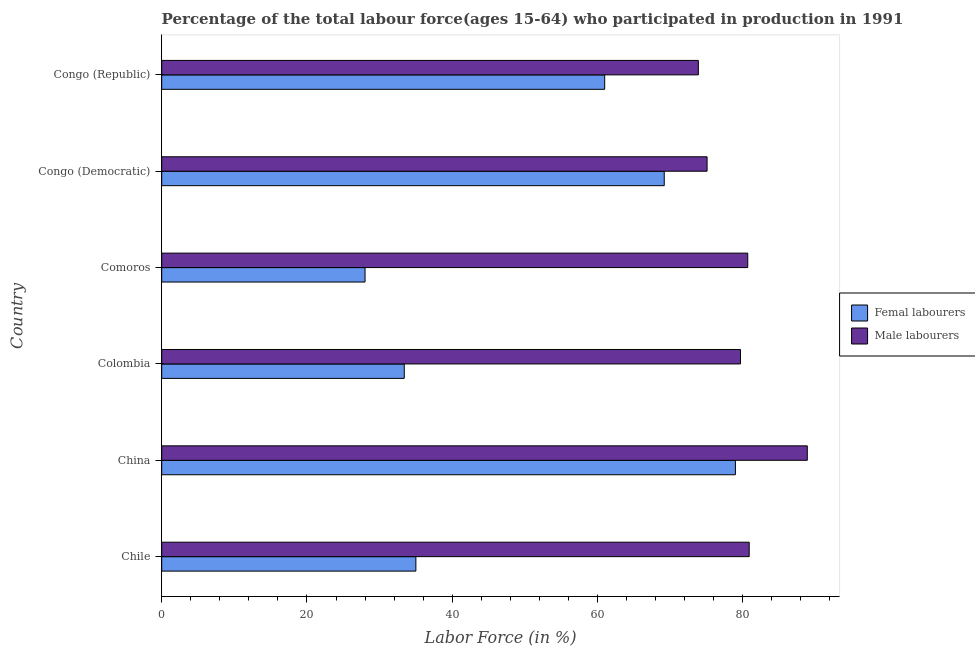How many bars are there on the 2nd tick from the bottom?
Your answer should be compact. 2. What is the label of the 3rd group of bars from the top?
Give a very brief answer. Comoros. In how many cases, is the number of bars for a given country not equal to the number of legend labels?
Give a very brief answer. 0. What is the percentage of male labour force in China?
Make the answer very short. 88.9. Across all countries, what is the maximum percentage of male labour force?
Ensure brevity in your answer.  88.9. Across all countries, what is the minimum percentage of female labor force?
Make the answer very short. 28. In which country was the percentage of female labor force maximum?
Provide a succinct answer. China. In which country was the percentage of male labour force minimum?
Ensure brevity in your answer.  Congo (Republic). What is the total percentage of female labor force in the graph?
Provide a succinct answer. 305.6. What is the difference between the percentage of female labor force in Colombia and the percentage of male labour force in Chile?
Provide a short and direct response. -47.5. What is the average percentage of female labor force per country?
Provide a short and direct response. 50.93. What is the ratio of the percentage of female labor force in Comoros to that in Congo (Republic)?
Your response must be concise. 0.46. Is the percentage of male labour force in Chile less than that in Congo (Democratic)?
Give a very brief answer. No. What is the difference between the highest and the second highest percentage of female labor force?
Keep it short and to the point. 9.8. In how many countries, is the percentage of female labor force greater than the average percentage of female labor force taken over all countries?
Offer a very short reply. 3. What does the 1st bar from the top in Chile represents?
Make the answer very short. Male labourers. What does the 1st bar from the bottom in Comoros represents?
Offer a very short reply. Femal labourers. Are all the bars in the graph horizontal?
Provide a short and direct response. Yes. What is the difference between two consecutive major ticks on the X-axis?
Give a very brief answer. 20. Does the graph contain any zero values?
Keep it short and to the point. No. How many legend labels are there?
Make the answer very short. 2. What is the title of the graph?
Make the answer very short. Percentage of the total labour force(ages 15-64) who participated in production in 1991. Does "Excluding technical cooperation" appear as one of the legend labels in the graph?
Your response must be concise. No. What is the label or title of the X-axis?
Your answer should be compact. Labor Force (in %). What is the label or title of the Y-axis?
Your response must be concise. Country. What is the Labor Force (in %) in Femal labourers in Chile?
Ensure brevity in your answer.  35. What is the Labor Force (in %) in Male labourers in Chile?
Offer a very short reply. 80.9. What is the Labor Force (in %) of Femal labourers in China?
Your answer should be compact. 79. What is the Labor Force (in %) in Male labourers in China?
Give a very brief answer. 88.9. What is the Labor Force (in %) in Femal labourers in Colombia?
Your response must be concise. 33.4. What is the Labor Force (in %) of Male labourers in Colombia?
Keep it short and to the point. 79.7. What is the Labor Force (in %) of Femal labourers in Comoros?
Keep it short and to the point. 28. What is the Labor Force (in %) in Male labourers in Comoros?
Your response must be concise. 80.7. What is the Labor Force (in %) in Femal labourers in Congo (Democratic)?
Give a very brief answer. 69.2. What is the Labor Force (in %) in Male labourers in Congo (Democratic)?
Offer a terse response. 75.1. What is the Labor Force (in %) of Femal labourers in Congo (Republic)?
Keep it short and to the point. 61. What is the Labor Force (in %) in Male labourers in Congo (Republic)?
Ensure brevity in your answer.  73.9. Across all countries, what is the maximum Labor Force (in %) of Femal labourers?
Offer a terse response. 79. Across all countries, what is the maximum Labor Force (in %) in Male labourers?
Offer a very short reply. 88.9. Across all countries, what is the minimum Labor Force (in %) of Femal labourers?
Your answer should be very brief. 28. Across all countries, what is the minimum Labor Force (in %) of Male labourers?
Ensure brevity in your answer.  73.9. What is the total Labor Force (in %) in Femal labourers in the graph?
Keep it short and to the point. 305.6. What is the total Labor Force (in %) in Male labourers in the graph?
Your answer should be compact. 479.2. What is the difference between the Labor Force (in %) of Femal labourers in Chile and that in China?
Ensure brevity in your answer.  -44. What is the difference between the Labor Force (in %) of Femal labourers in Chile and that in Colombia?
Keep it short and to the point. 1.6. What is the difference between the Labor Force (in %) in Femal labourers in Chile and that in Comoros?
Offer a very short reply. 7. What is the difference between the Labor Force (in %) in Male labourers in Chile and that in Comoros?
Offer a very short reply. 0.2. What is the difference between the Labor Force (in %) in Femal labourers in Chile and that in Congo (Democratic)?
Your response must be concise. -34.2. What is the difference between the Labor Force (in %) in Male labourers in Chile and that in Congo (Democratic)?
Your answer should be very brief. 5.8. What is the difference between the Labor Force (in %) of Femal labourers in China and that in Colombia?
Make the answer very short. 45.6. What is the difference between the Labor Force (in %) of Femal labourers in China and that in Comoros?
Offer a terse response. 51. What is the difference between the Labor Force (in %) of Male labourers in China and that in Comoros?
Give a very brief answer. 8.2. What is the difference between the Labor Force (in %) in Male labourers in China and that in Congo (Democratic)?
Your response must be concise. 13.8. What is the difference between the Labor Force (in %) in Femal labourers in China and that in Congo (Republic)?
Your answer should be compact. 18. What is the difference between the Labor Force (in %) of Femal labourers in Colombia and that in Congo (Democratic)?
Your response must be concise. -35.8. What is the difference between the Labor Force (in %) of Femal labourers in Colombia and that in Congo (Republic)?
Your answer should be very brief. -27.6. What is the difference between the Labor Force (in %) of Femal labourers in Comoros and that in Congo (Democratic)?
Offer a very short reply. -41.2. What is the difference between the Labor Force (in %) of Femal labourers in Comoros and that in Congo (Republic)?
Ensure brevity in your answer.  -33. What is the difference between the Labor Force (in %) of Male labourers in Congo (Democratic) and that in Congo (Republic)?
Ensure brevity in your answer.  1.2. What is the difference between the Labor Force (in %) in Femal labourers in Chile and the Labor Force (in %) in Male labourers in China?
Provide a succinct answer. -53.9. What is the difference between the Labor Force (in %) in Femal labourers in Chile and the Labor Force (in %) in Male labourers in Colombia?
Your answer should be very brief. -44.7. What is the difference between the Labor Force (in %) in Femal labourers in Chile and the Labor Force (in %) in Male labourers in Comoros?
Provide a succinct answer. -45.7. What is the difference between the Labor Force (in %) in Femal labourers in Chile and the Labor Force (in %) in Male labourers in Congo (Democratic)?
Give a very brief answer. -40.1. What is the difference between the Labor Force (in %) of Femal labourers in Chile and the Labor Force (in %) of Male labourers in Congo (Republic)?
Your answer should be very brief. -38.9. What is the difference between the Labor Force (in %) in Femal labourers in China and the Labor Force (in %) in Male labourers in Congo (Democratic)?
Provide a succinct answer. 3.9. What is the difference between the Labor Force (in %) of Femal labourers in China and the Labor Force (in %) of Male labourers in Congo (Republic)?
Offer a terse response. 5.1. What is the difference between the Labor Force (in %) in Femal labourers in Colombia and the Labor Force (in %) in Male labourers in Comoros?
Keep it short and to the point. -47.3. What is the difference between the Labor Force (in %) in Femal labourers in Colombia and the Labor Force (in %) in Male labourers in Congo (Democratic)?
Provide a short and direct response. -41.7. What is the difference between the Labor Force (in %) of Femal labourers in Colombia and the Labor Force (in %) of Male labourers in Congo (Republic)?
Provide a succinct answer. -40.5. What is the difference between the Labor Force (in %) of Femal labourers in Comoros and the Labor Force (in %) of Male labourers in Congo (Democratic)?
Make the answer very short. -47.1. What is the difference between the Labor Force (in %) of Femal labourers in Comoros and the Labor Force (in %) of Male labourers in Congo (Republic)?
Your response must be concise. -45.9. What is the average Labor Force (in %) of Femal labourers per country?
Offer a very short reply. 50.93. What is the average Labor Force (in %) in Male labourers per country?
Make the answer very short. 79.87. What is the difference between the Labor Force (in %) of Femal labourers and Labor Force (in %) of Male labourers in Chile?
Your answer should be compact. -45.9. What is the difference between the Labor Force (in %) in Femal labourers and Labor Force (in %) in Male labourers in China?
Offer a very short reply. -9.9. What is the difference between the Labor Force (in %) of Femal labourers and Labor Force (in %) of Male labourers in Colombia?
Your answer should be very brief. -46.3. What is the difference between the Labor Force (in %) in Femal labourers and Labor Force (in %) in Male labourers in Comoros?
Offer a very short reply. -52.7. What is the ratio of the Labor Force (in %) of Femal labourers in Chile to that in China?
Provide a short and direct response. 0.44. What is the ratio of the Labor Force (in %) in Male labourers in Chile to that in China?
Your answer should be very brief. 0.91. What is the ratio of the Labor Force (in %) of Femal labourers in Chile to that in Colombia?
Your answer should be very brief. 1.05. What is the ratio of the Labor Force (in %) of Male labourers in Chile to that in Colombia?
Keep it short and to the point. 1.02. What is the ratio of the Labor Force (in %) of Male labourers in Chile to that in Comoros?
Your response must be concise. 1. What is the ratio of the Labor Force (in %) of Femal labourers in Chile to that in Congo (Democratic)?
Provide a succinct answer. 0.51. What is the ratio of the Labor Force (in %) in Male labourers in Chile to that in Congo (Democratic)?
Provide a succinct answer. 1.08. What is the ratio of the Labor Force (in %) of Femal labourers in Chile to that in Congo (Republic)?
Provide a short and direct response. 0.57. What is the ratio of the Labor Force (in %) in Male labourers in Chile to that in Congo (Republic)?
Your answer should be very brief. 1.09. What is the ratio of the Labor Force (in %) of Femal labourers in China to that in Colombia?
Provide a short and direct response. 2.37. What is the ratio of the Labor Force (in %) of Male labourers in China to that in Colombia?
Make the answer very short. 1.12. What is the ratio of the Labor Force (in %) of Femal labourers in China to that in Comoros?
Offer a terse response. 2.82. What is the ratio of the Labor Force (in %) in Male labourers in China to that in Comoros?
Your response must be concise. 1.1. What is the ratio of the Labor Force (in %) of Femal labourers in China to that in Congo (Democratic)?
Keep it short and to the point. 1.14. What is the ratio of the Labor Force (in %) in Male labourers in China to that in Congo (Democratic)?
Make the answer very short. 1.18. What is the ratio of the Labor Force (in %) in Femal labourers in China to that in Congo (Republic)?
Provide a short and direct response. 1.3. What is the ratio of the Labor Force (in %) in Male labourers in China to that in Congo (Republic)?
Your response must be concise. 1.2. What is the ratio of the Labor Force (in %) of Femal labourers in Colombia to that in Comoros?
Offer a terse response. 1.19. What is the ratio of the Labor Force (in %) in Male labourers in Colombia to that in Comoros?
Your response must be concise. 0.99. What is the ratio of the Labor Force (in %) in Femal labourers in Colombia to that in Congo (Democratic)?
Provide a short and direct response. 0.48. What is the ratio of the Labor Force (in %) in Male labourers in Colombia to that in Congo (Democratic)?
Make the answer very short. 1.06. What is the ratio of the Labor Force (in %) in Femal labourers in Colombia to that in Congo (Republic)?
Offer a terse response. 0.55. What is the ratio of the Labor Force (in %) in Male labourers in Colombia to that in Congo (Republic)?
Offer a very short reply. 1.08. What is the ratio of the Labor Force (in %) in Femal labourers in Comoros to that in Congo (Democratic)?
Make the answer very short. 0.4. What is the ratio of the Labor Force (in %) of Male labourers in Comoros to that in Congo (Democratic)?
Your response must be concise. 1.07. What is the ratio of the Labor Force (in %) of Femal labourers in Comoros to that in Congo (Republic)?
Your response must be concise. 0.46. What is the ratio of the Labor Force (in %) in Male labourers in Comoros to that in Congo (Republic)?
Your answer should be very brief. 1.09. What is the ratio of the Labor Force (in %) in Femal labourers in Congo (Democratic) to that in Congo (Republic)?
Your answer should be compact. 1.13. What is the ratio of the Labor Force (in %) of Male labourers in Congo (Democratic) to that in Congo (Republic)?
Ensure brevity in your answer.  1.02. What is the difference between the highest and the second highest Labor Force (in %) of Femal labourers?
Make the answer very short. 9.8. What is the difference between the highest and the lowest Labor Force (in %) in Femal labourers?
Provide a short and direct response. 51. 